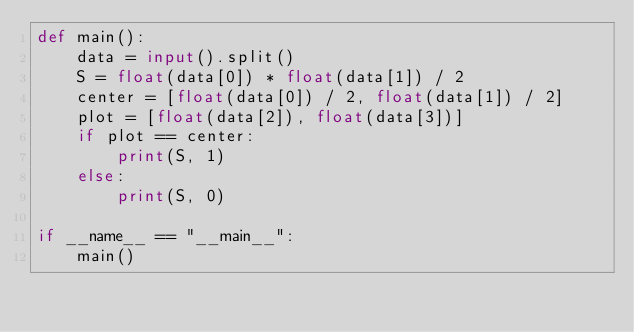<code> <loc_0><loc_0><loc_500><loc_500><_Python_>def main():
    data = input().split()
    S = float(data[0]) * float(data[1]) / 2
    center = [float(data[0]) / 2, float(data[1]) / 2]
    plot = [float(data[2]), float(data[3])]
    if plot == center:
        print(S, 1)
    else:
        print(S, 0)

if __name__ == "__main__":
    main()</code> 